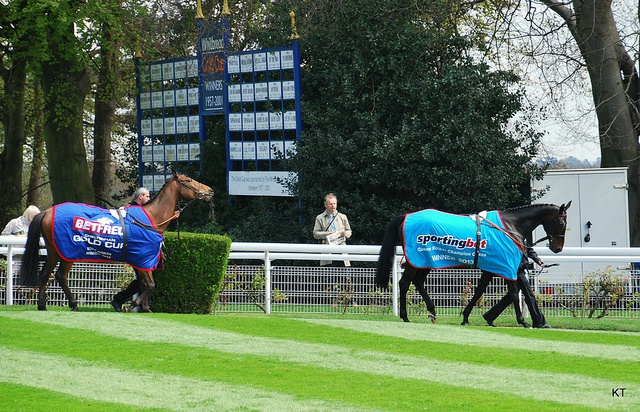Describe the objects in this image and their specific colors. I can see horse in khaki, black, lightblue, cyan, and teal tones, horse in khaki, black, navy, lightblue, and darkblue tones, truck in khaki, lightgray, darkgray, and gray tones, people in khaki, ivory, darkgray, gray, and lightgray tones, and people in khaki, lightgray, darkgray, and tan tones in this image. 